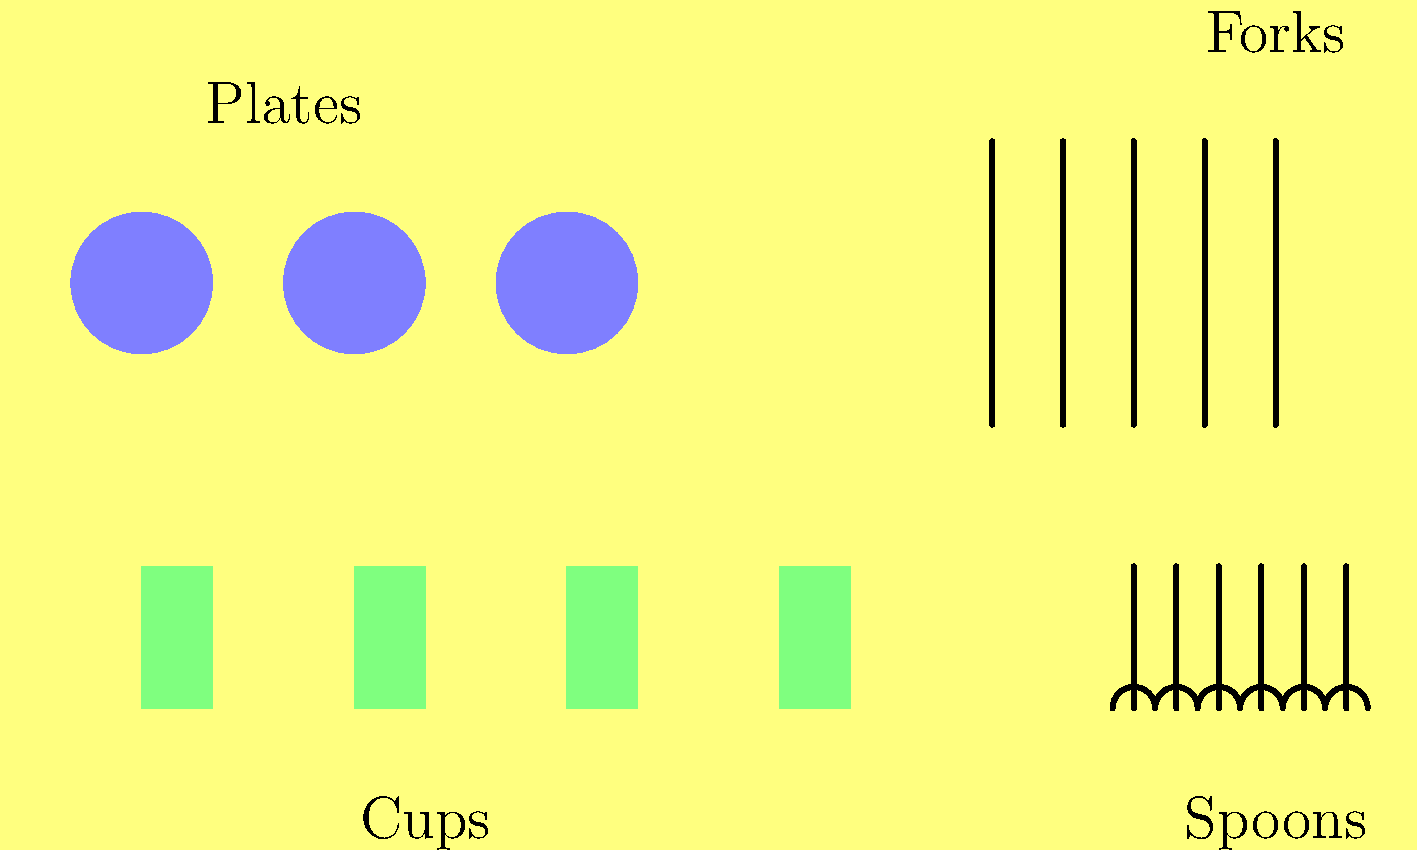In the kitchen scene, count the total number of items and determine how many groups they form. Then, calculate the average number of items per group, rounding to the nearest whole number. Let's approach this step-by-step:

1. Count the total number of items:
   - Plates: 3
   - Cups: 4
   - Forks: 5
   - Spoons: 6
   Total items: $3 + 4 + 5 + 6 = 18$

2. Determine the number of groups:
   There are 4 distinct groups: plates, cups, forks, and spoons.

3. Calculate the average number of items per group:
   Average = Total items ÷ Number of groups
   $\text{Average} = \frac{18}{4} = 4.5$

4. Round to the nearest whole number:
   4.5 rounds up to 5.

Therefore, there are 18 total items in 4 groups, with an average of 5 items per group when rounded to the nearest whole number.
Answer: 18 items, 4 groups, 5 items per group on average 